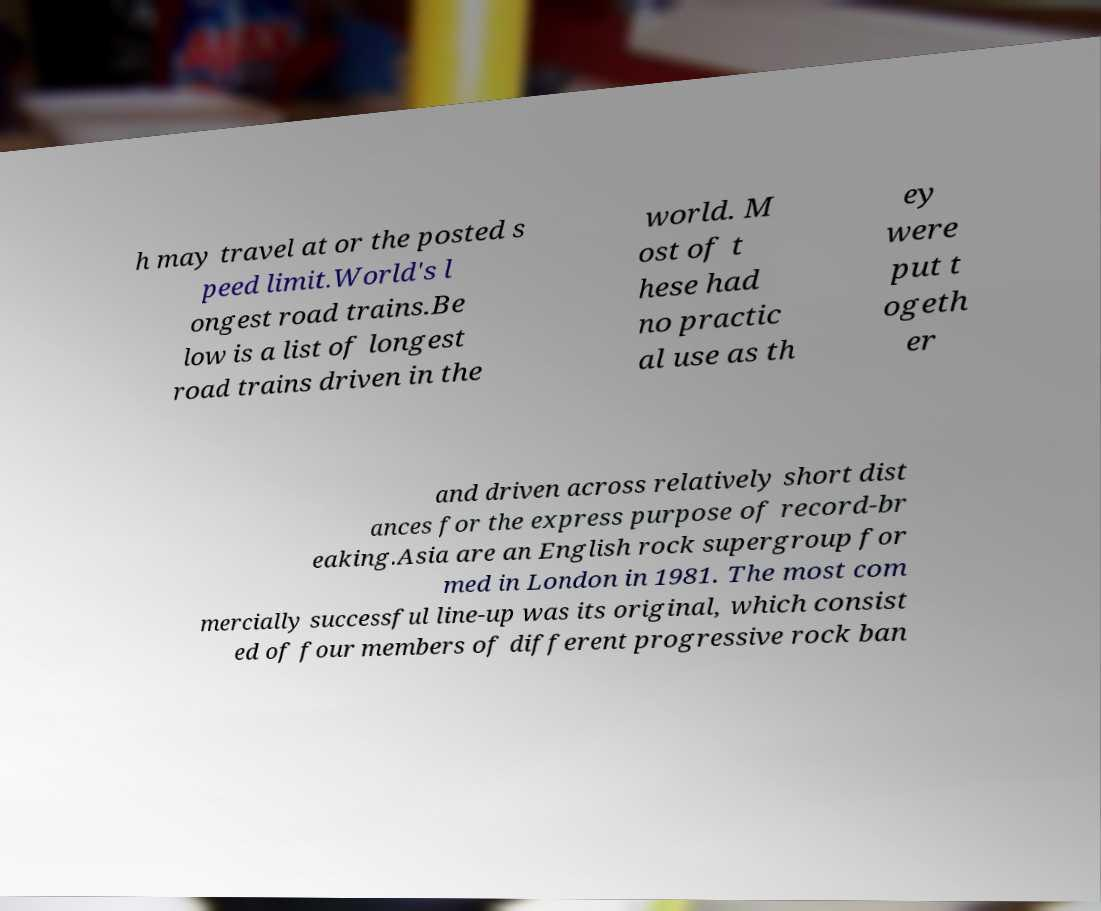Please read and relay the text visible in this image. What does it say? h may travel at or the posted s peed limit.World's l ongest road trains.Be low is a list of longest road trains driven in the world. M ost of t hese had no practic al use as th ey were put t ogeth er and driven across relatively short dist ances for the express purpose of record-br eaking.Asia are an English rock supergroup for med in London in 1981. The most com mercially successful line-up was its original, which consist ed of four members of different progressive rock ban 